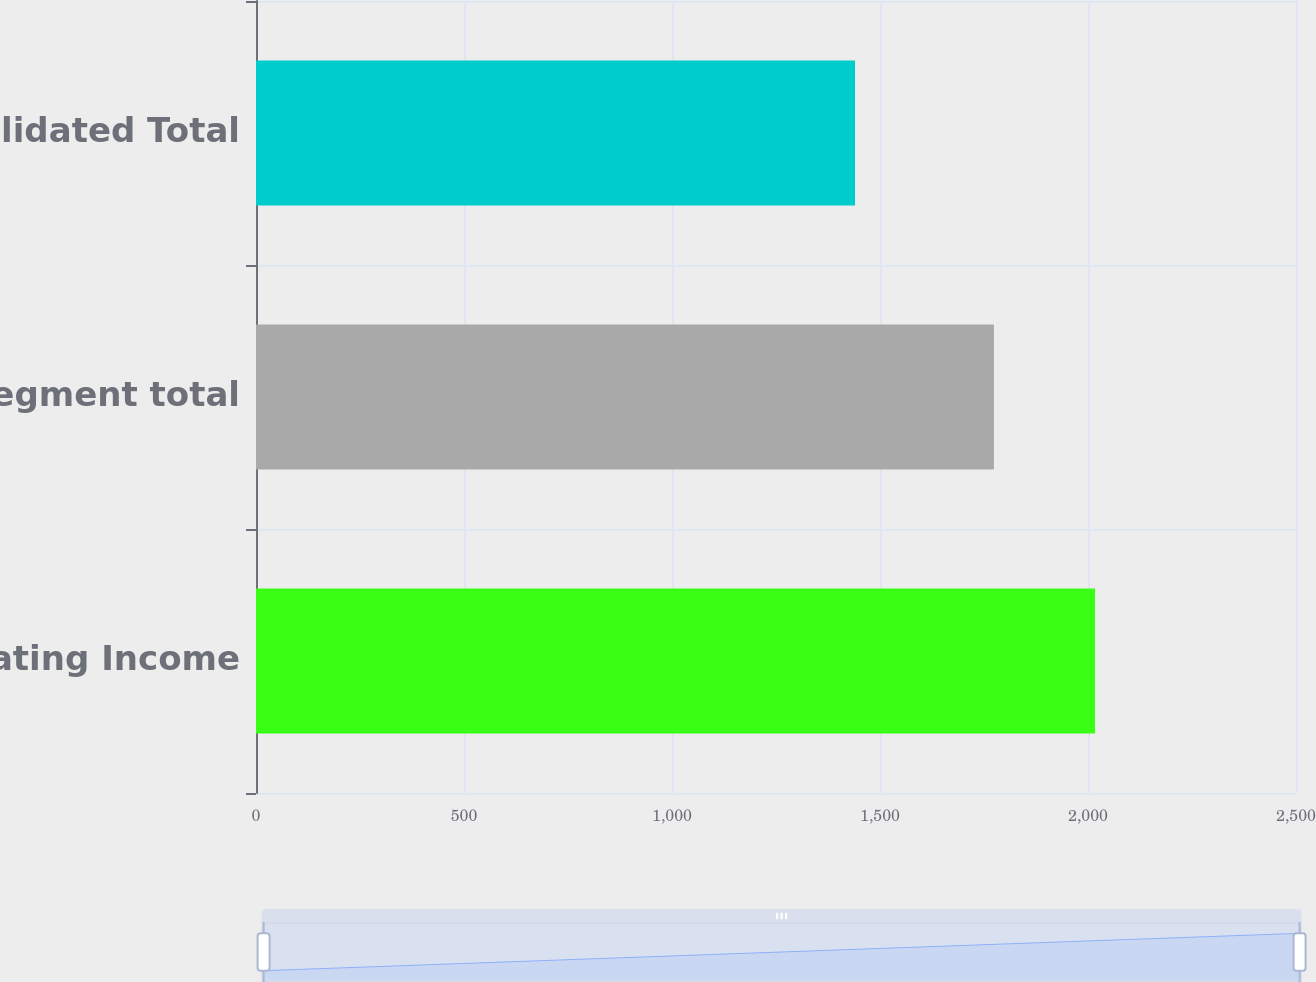Convert chart. <chart><loc_0><loc_0><loc_500><loc_500><bar_chart><fcel>Operating Income<fcel>Segment total<fcel>Consolidated Total<nl><fcel>2017<fcel>1773.8<fcel>1440<nl></chart> 